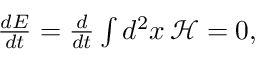<formula> <loc_0><loc_0><loc_500><loc_500>\begin{array} { r } { \frac { d E } { d t } = \frac { d } { d t } \int d ^ { 2 } x \, \mathcal { H } = 0 , } \end{array}</formula> 